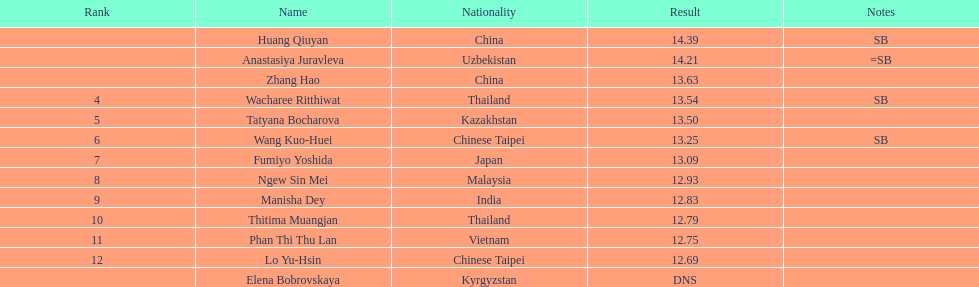From thailand, how many contestants took part? 2. 